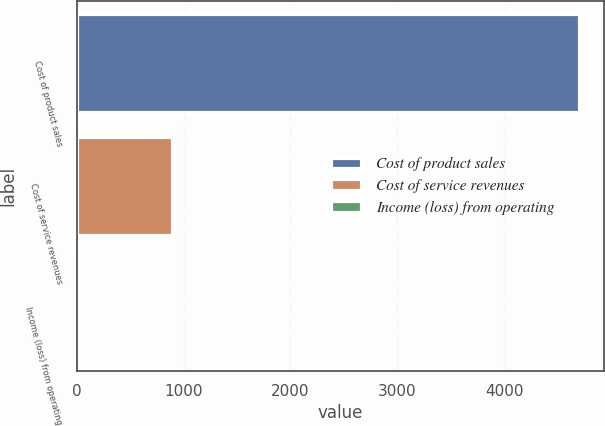Convert chart to OTSL. <chart><loc_0><loc_0><loc_500><loc_500><bar_chart><fcel>Cost of product sales<fcel>Cost of service revenues<fcel>Income (loss) from operating<nl><fcel>4695<fcel>888<fcel>14<nl></chart> 